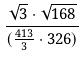Convert formula to latex. <formula><loc_0><loc_0><loc_500><loc_500>\frac { \sqrt { 3 } \cdot \sqrt { 1 6 8 } } { ( \frac { 4 1 3 } { 3 } \cdot 3 2 6 ) }</formula> 